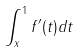<formula> <loc_0><loc_0><loc_500><loc_500>\int _ { x } ^ { 1 } f ^ { \prime } ( t ) d t</formula> 